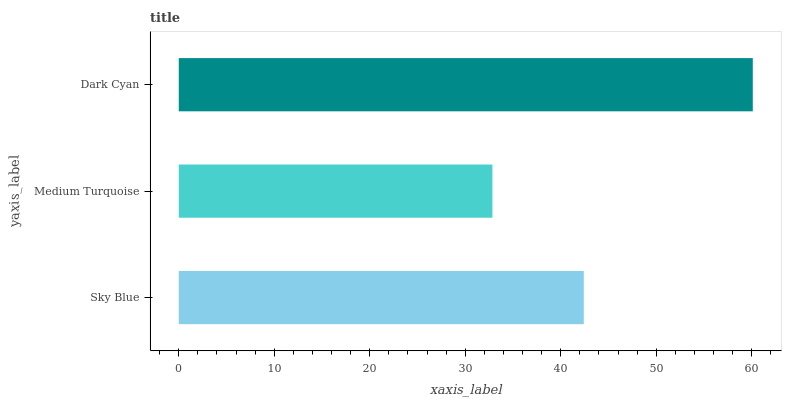Is Medium Turquoise the minimum?
Answer yes or no. Yes. Is Dark Cyan the maximum?
Answer yes or no. Yes. Is Dark Cyan the minimum?
Answer yes or no. No. Is Medium Turquoise the maximum?
Answer yes or no. No. Is Dark Cyan greater than Medium Turquoise?
Answer yes or no. Yes. Is Medium Turquoise less than Dark Cyan?
Answer yes or no. Yes. Is Medium Turquoise greater than Dark Cyan?
Answer yes or no. No. Is Dark Cyan less than Medium Turquoise?
Answer yes or no. No. Is Sky Blue the high median?
Answer yes or no. Yes. Is Sky Blue the low median?
Answer yes or no. Yes. Is Medium Turquoise the high median?
Answer yes or no. No. Is Dark Cyan the low median?
Answer yes or no. No. 